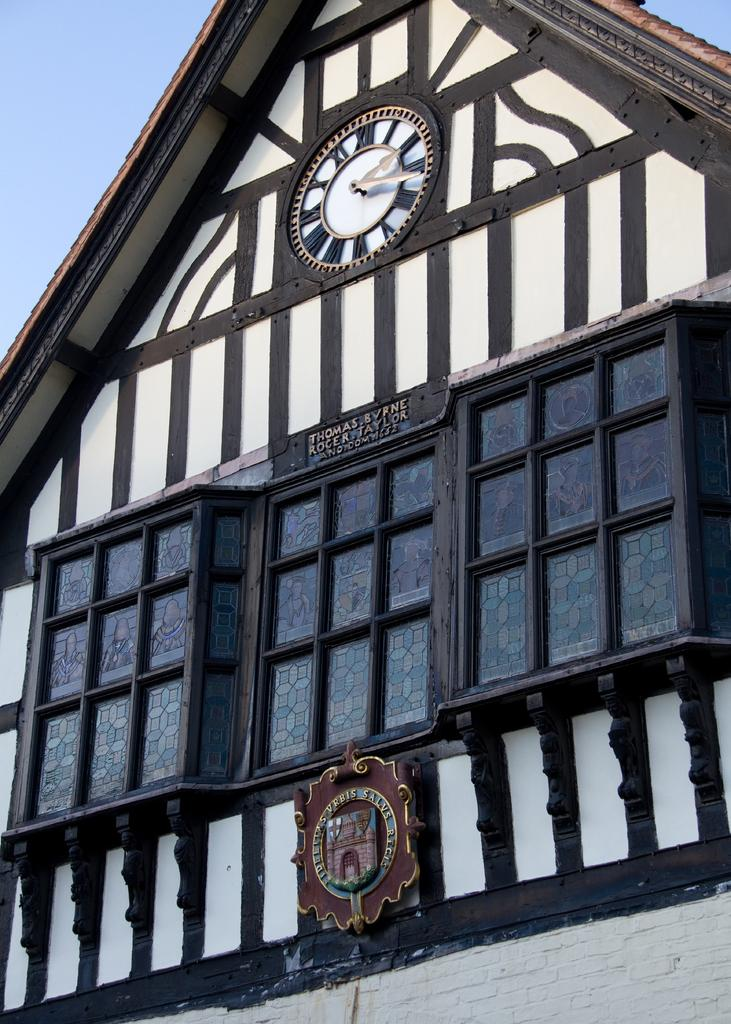What type of structure is present in the image? There is a building in the image. What feature can be seen on the building? There is a clock on the building. What else is visible in the image besides the building and clock? There is a board with writing in the image. Can you see a donkey helping to hold the board in the image? No, there is no donkey present in the image. 